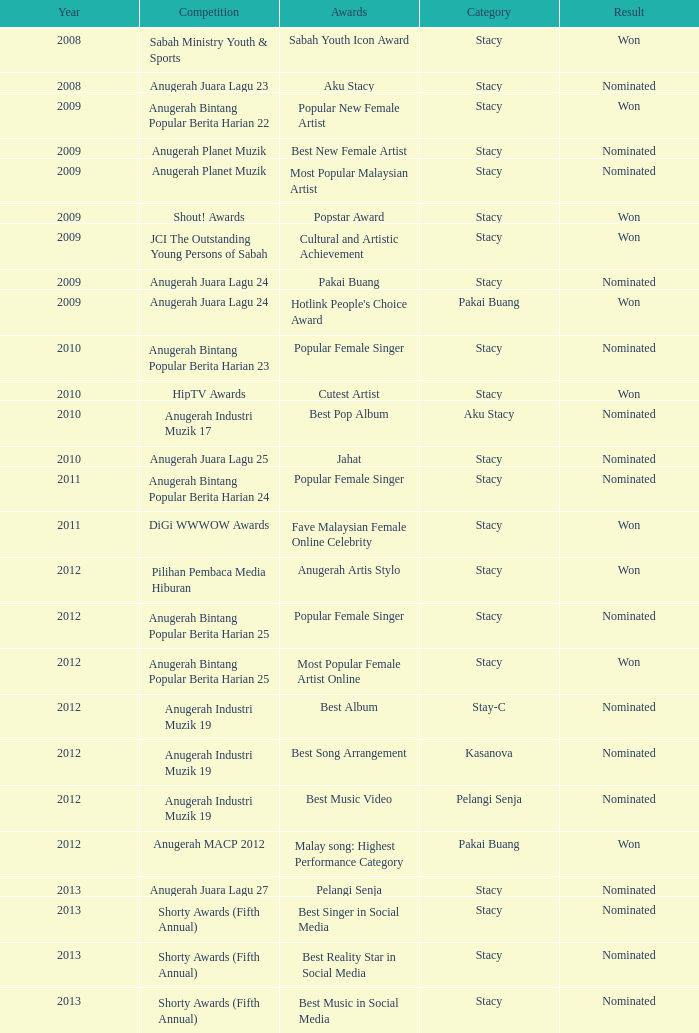What was the effect in the years beyond 2008 with an award of jahat and a category of stacy? Nominated. 